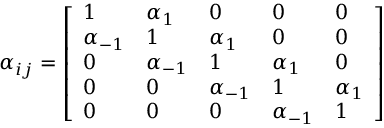<formula> <loc_0><loc_0><loc_500><loc_500>\alpha _ { i j } = { \left [ \begin{array} { l l l l l } { 1 } & { \alpha _ { 1 } } & { 0 } & { 0 } & { 0 } \\ { \alpha _ { - 1 } } & { 1 } & { \alpha _ { 1 } } & { 0 } & { 0 } \\ { 0 } & { \alpha _ { - 1 } } & { 1 } & { \alpha _ { 1 } } & { 0 } \\ { 0 } & { 0 } & { \alpha _ { - 1 } } & { 1 } & { \alpha _ { 1 } } \\ { 0 } & { 0 } & { 0 } & { \alpha _ { - 1 } } & { 1 } \end{array} \right ] }</formula> 